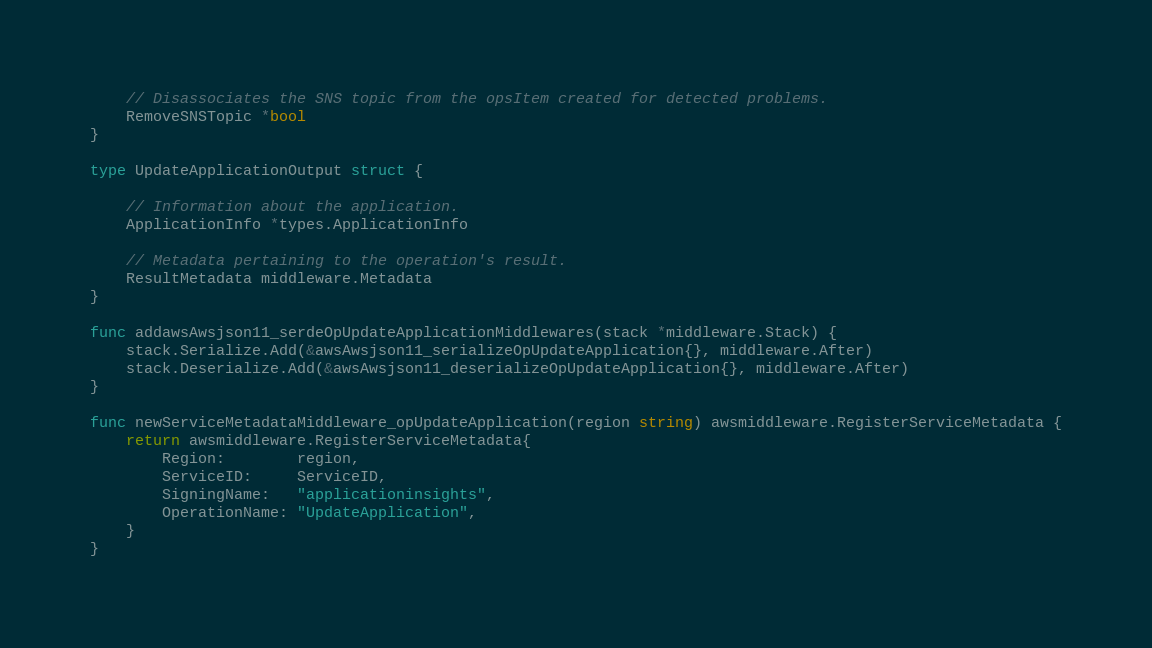<code> <loc_0><loc_0><loc_500><loc_500><_Go_>	// Disassociates the SNS topic from the opsItem created for detected problems.
	RemoveSNSTopic *bool
}

type UpdateApplicationOutput struct {

	// Information about the application.
	ApplicationInfo *types.ApplicationInfo

	// Metadata pertaining to the operation's result.
	ResultMetadata middleware.Metadata
}

func addawsAwsjson11_serdeOpUpdateApplicationMiddlewares(stack *middleware.Stack) {
	stack.Serialize.Add(&awsAwsjson11_serializeOpUpdateApplication{}, middleware.After)
	stack.Deserialize.Add(&awsAwsjson11_deserializeOpUpdateApplication{}, middleware.After)
}

func newServiceMetadataMiddleware_opUpdateApplication(region string) awsmiddleware.RegisterServiceMetadata {
	return awsmiddleware.RegisterServiceMetadata{
		Region:        region,
		ServiceID:     ServiceID,
		SigningName:   "applicationinsights",
		OperationName: "UpdateApplication",
	}
}
</code> 